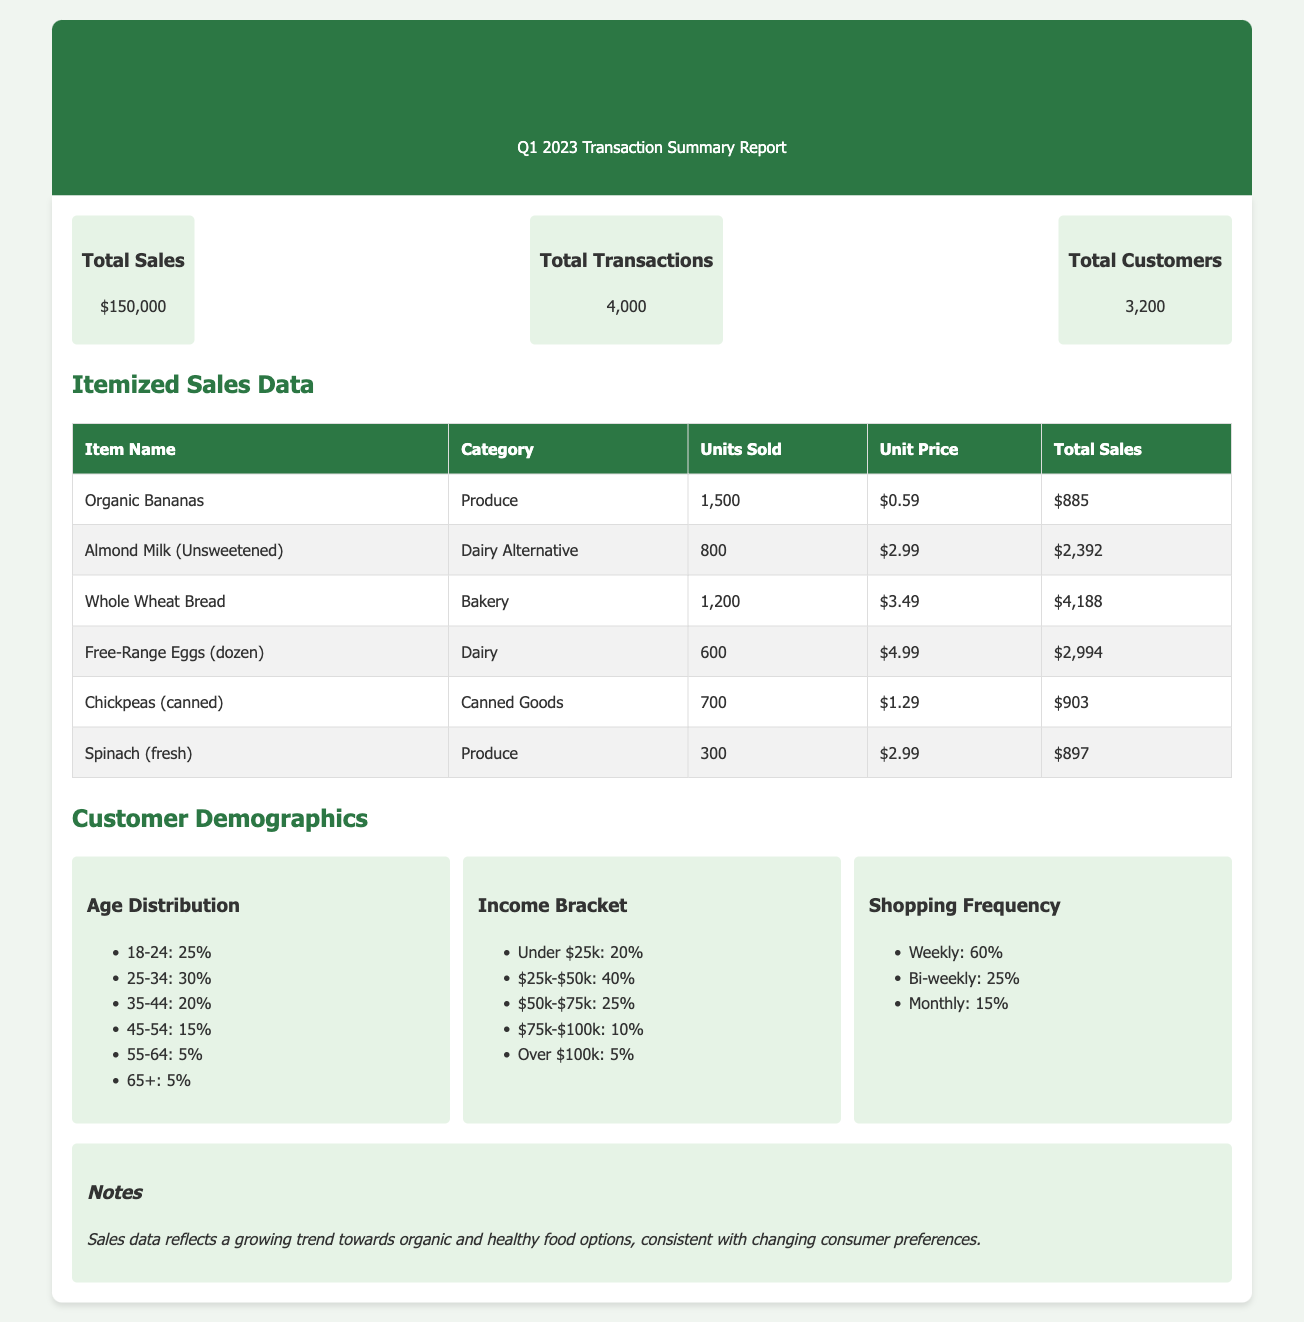What was the total sales amount? The total sales amount is provided in the summary section of the document, which states the total sales for Q1 2023.
Answer: $150,000 How many total transactions were recorded? The total transactions figure can be found in the summary section, indicating the number of transactions for the quarter.
Answer: 4,000 What percentage of customers fall within the age group 25-34? The age distribution chart specifies the percentage of customers in the 25-34 age range.
Answer: 30% Which item had the highest sales in total? By reviewing the itemized sales data, the item with the highest total sales amount can be determined.
Answer: Whole Wheat Bread What is the shopping frequency percentage for monthly shoppers? The shopping frequency chart provides the percentage of customers who shop monthly, which can be directly referenced.
Answer: 15% What is the lowest income bracket percentage among customers? The income bracket chart details the various income levels and their respective customer percentages; the lowest can be identified.
Answer: 5% How many units of Organic Bananas were sold? This information is available in the itemized sales data, specifying the units sold for Organic Bananas.
Answer: 1,500 What is the percentage of customers with an income of $25K-$50K? The income bracket chart lists the percentage of customers within this particular income range.
Answer: 40% What is noted about the sales data trends? The notes section highlights the trends observed in the sales data regarding consumer preferences.
Answer: Organic and healthy food options 